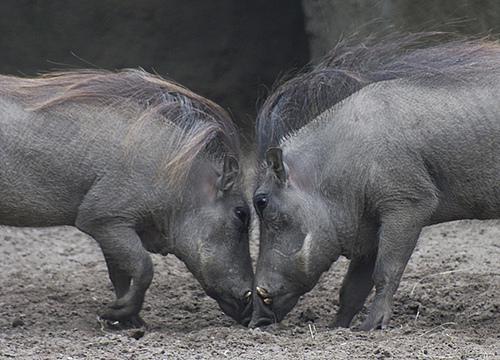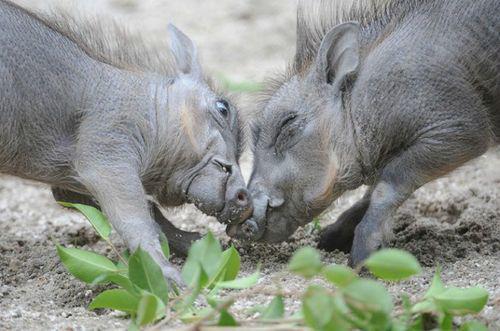The first image is the image on the left, the second image is the image on the right. For the images displayed, is the sentence "There are two pairs of warthogs standing with their faces touching." factually correct? Answer yes or no. Yes. The first image is the image on the left, the second image is the image on the right. Examine the images to the left and right. Is the description "Both images show a pair of warthogs posed face-to-face." accurate? Answer yes or no. Yes. 